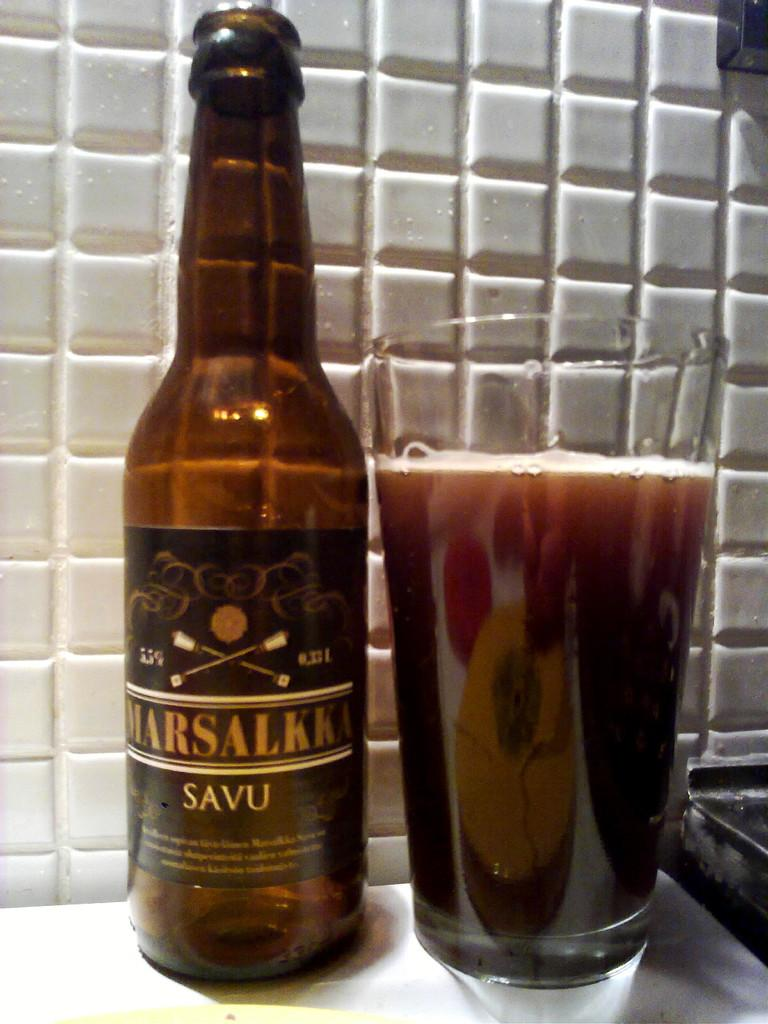Provide a one-sentence caption for the provided image. A bottle of Marsalkka beer next to a pint glass of it. 